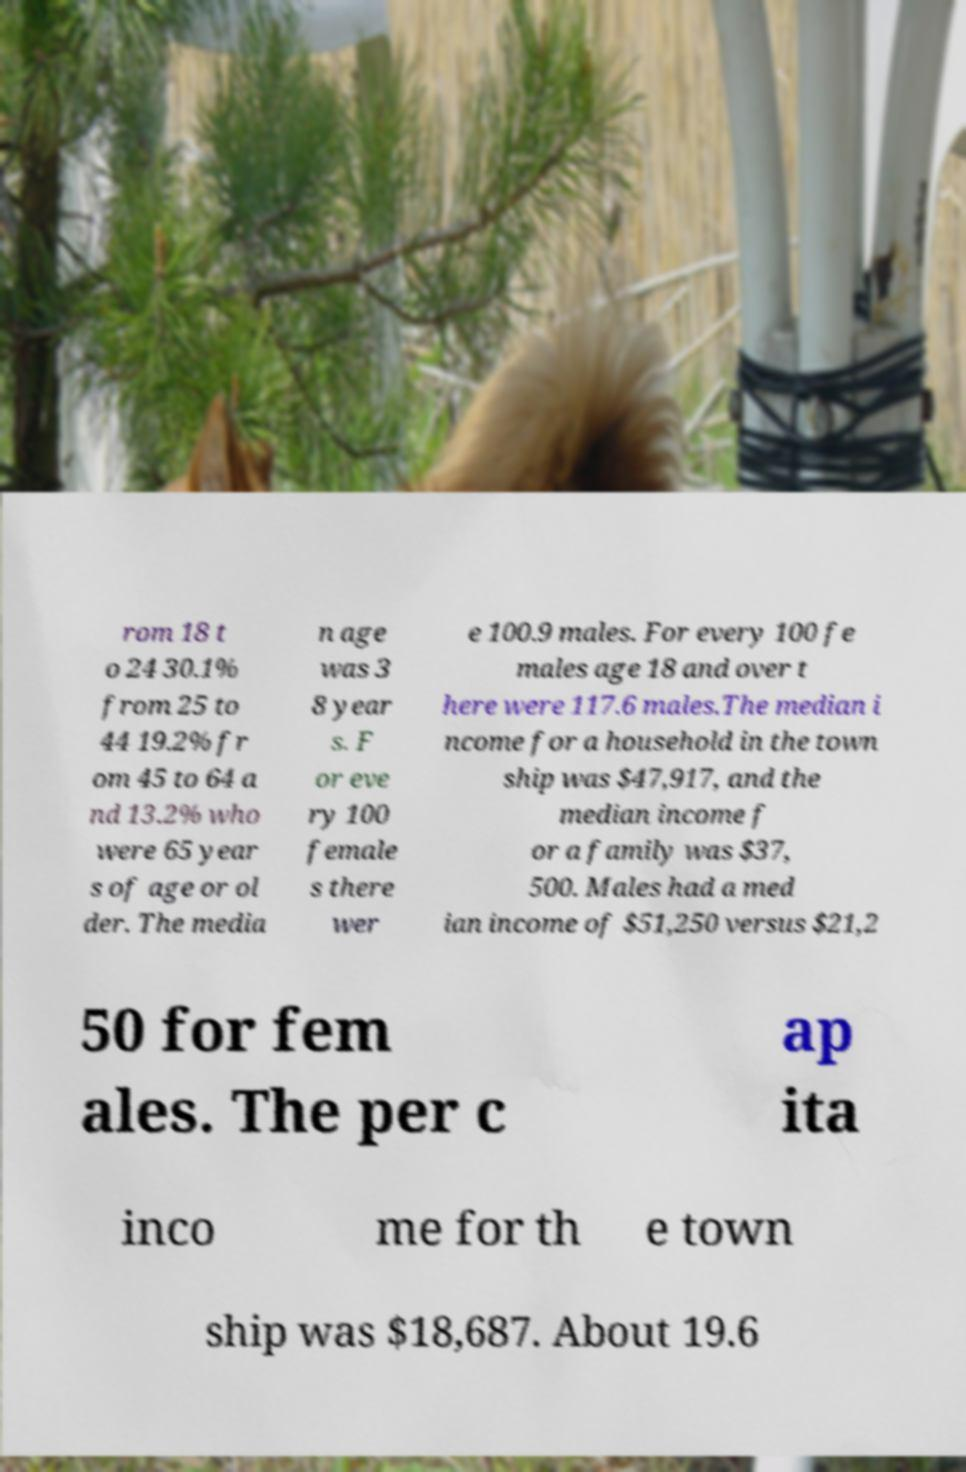Could you extract and type out the text from this image? rom 18 t o 24 30.1% from 25 to 44 19.2% fr om 45 to 64 a nd 13.2% who were 65 year s of age or ol der. The media n age was 3 8 year s. F or eve ry 100 female s there wer e 100.9 males. For every 100 fe males age 18 and over t here were 117.6 males.The median i ncome for a household in the town ship was $47,917, and the median income f or a family was $37, 500. Males had a med ian income of $51,250 versus $21,2 50 for fem ales. The per c ap ita inco me for th e town ship was $18,687. About 19.6 